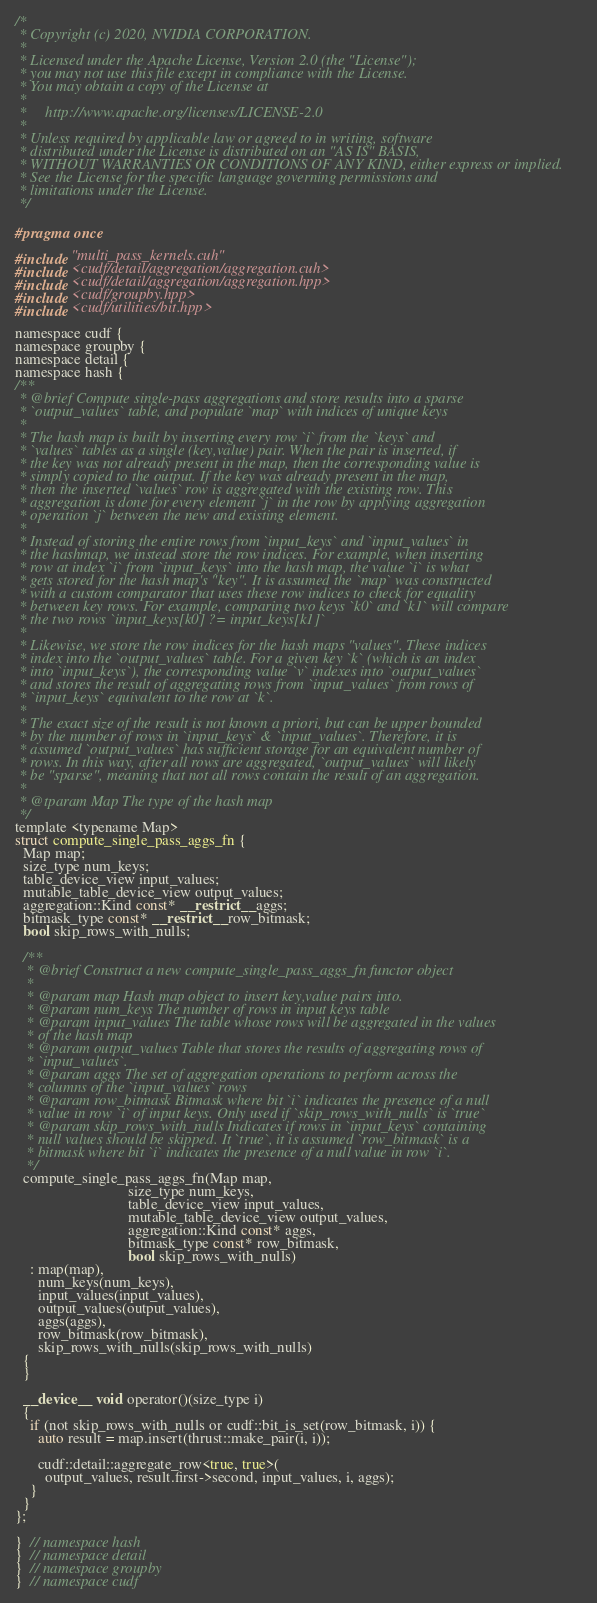Convert code to text. <code><loc_0><loc_0><loc_500><loc_500><_Cuda_>/*
 * Copyright (c) 2020, NVIDIA CORPORATION.
 *
 * Licensed under the Apache License, Version 2.0 (the "License");
 * you may not use this file except in compliance with the License.
 * You may obtain a copy of the License at
 *
 *     http://www.apache.org/licenses/LICENSE-2.0
 *
 * Unless required by applicable law or agreed to in writing, software
 * distributed under the License is distributed on an "AS IS" BASIS,
 * WITHOUT WARRANTIES OR CONDITIONS OF ANY KIND, either express or implied.
 * See the License for the specific language governing permissions and
 * limitations under the License.
 */

#pragma once

#include "multi_pass_kernels.cuh"
#include <cudf/detail/aggregation/aggregation.cuh>
#include <cudf/detail/aggregation/aggregation.hpp>
#include <cudf/groupby.hpp>
#include <cudf/utilities/bit.hpp>

namespace cudf {
namespace groupby {
namespace detail {
namespace hash {
/**
 * @brief Compute single-pass aggregations and store results into a sparse
 * `output_values` table, and populate `map` with indices of unique keys
 *
 * The hash map is built by inserting every row `i` from the `keys` and
 * `values` tables as a single (key,value) pair. When the pair is inserted, if
 * the key was not already present in the map, then the corresponding value is
 * simply copied to the output. If the key was already present in the map,
 * then the inserted `values` row is aggregated with the existing row. This
 * aggregation is done for every element `j` in the row by applying aggregation
 * operation `j` between the new and existing element.
 *
 * Instead of storing the entire rows from `input_keys` and `input_values` in
 * the hashmap, we instead store the row indices. For example, when inserting
 * row at index `i` from `input_keys` into the hash map, the value `i` is what
 * gets stored for the hash map's "key". It is assumed the `map` was constructed
 * with a custom comparator that uses these row indices to check for equality
 * between key rows. For example, comparing two keys `k0` and `k1` will compare
 * the two rows `input_keys[k0] ?= input_keys[k1]`
 *
 * Likewise, we store the row indices for the hash maps "values". These indices
 * index into the `output_values` table. For a given key `k` (which is an index
 * into `input_keys`), the corresponding value `v` indexes into `output_values`
 * and stores the result of aggregating rows from `input_values` from rows of
 * `input_keys` equivalent to the row at `k`.
 *
 * The exact size of the result is not known a priori, but can be upper bounded
 * by the number of rows in `input_keys` & `input_values`. Therefore, it is
 * assumed `output_values` has sufficient storage for an equivalent number of
 * rows. In this way, after all rows are aggregated, `output_values` will likely
 * be "sparse", meaning that not all rows contain the result of an aggregation.
 *
 * @tparam Map The type of the hash map
 */
template <typename Map>
struct compute_single_pass_aggs_fn {
  Map map;
  size_type num_keys;
  table_device_view input_values;
  mutable_table_device_view output_values;
  aggregation::Kind const* __restrict__ aggs;
  bitmask_type const* __restrict__ row_bitmask;
  bool skip_rows_with_nulls;

  /**
   * @brief Construct a new compute_single_pass_aggs_fn functor object
   *
   * @param map Hash map object to insert key,value pairs into.
   * @param num_keys The number of rows in input keys table
   * @param input_values The table whose rows will be aggregated in the values
   * of the hash map
   * @param output_values Table that stores the results of aggregating rows of
   * `input_values`.
   * @param aggs The set of aggregation operations to perform across the
   * columns of the `input_values` rows
   * @param row_bitmask Bitmask where bit `i` indicates the presence of a null
   * value in row `i` of input keys. Only used if `skip_rows_with_nulls` is `true`
   * @param skip_rows_with_nulls Indicates if rows in `input_keys` containing
   * null values should be skipped. It `true`, it is assumed `row_bitmask` is a
   * bitmask where bit `i` indicates the presence of a null value in row `i`.
   */
  compute_single_pass_aggs_fn(Map map,
                              size_type num_keys,
                              table_device_view input_values,
                              mutable_table_device_view output_values,
                              aggregation::Kind const* aggs,
                              bitmask_type const* row_bitmask,
                              bool skip_rows_with_nulls)
    : map(map),
      num_keys(num_keys),
      input_values(input_values),
      output_values(output_values),
      aggs(aggs),
      row_bitmask(row_bitmask),
      skip_rows_with_nulls(skip_rows_with_nulls)
  {
  }

  __device__ void operator()(size_type i)
  {
    if (not skip_rows_with_nulls or cudf::bit_is_set(row_bitmask, i)) {
      auto result = map.insert(thrust::make_pair(i, i));

      cudf::detail::aggregate_row<true, true>(
        output_values, result.first->second, input_values, i, aggs);
    }
  }
};

}  // namespace hash
}  // namespace detail
}  // namespace groupby
}  // namespace cudf
</code> 